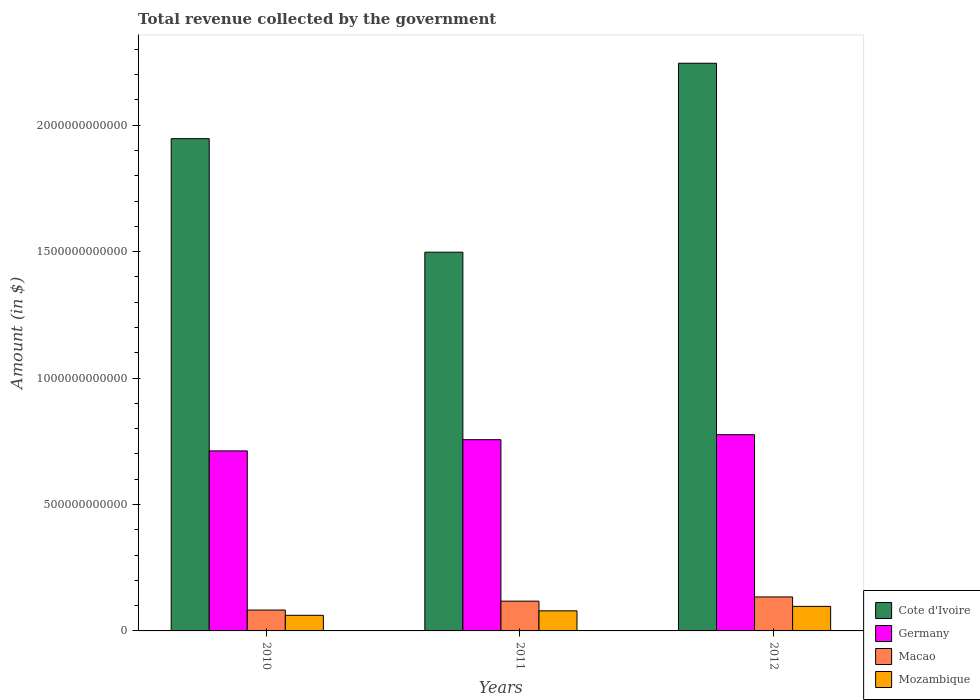How many different coloured bars are there?
Provide a short and direct response. 4. Are the number of bars per tick equal to the number of legend labels?
Offer a very short reply. Yes. How many bars are there on the 3rd tick from the left?
Offer a terse response. 4. In how many cases, is the number of bars for a given year not equal to the number of legend labels?
Keep it short and to the point. 0. What is the total revenue collected by the government in Cote d'Ivoire in 2012?
Give a very brief answer. 2.24e+12. Across all years, what is the maximum total revenue collected by the government in Germany?
Ensure brevity in your answer.  7.76e+11. Across all years, what is the minimum total revenue collected by the government in Cote d'Ivoire?
Provide a succinct answer. 1.50e+12. In which year was the total revenue collected by the government in Germany maximum?
Your answer should be very brief. 2012. What is the total total revenue collected by the government in Cote d'Ivoire in the graph?
Your answer should be compact. 5.69e+12. What is the difference between the total revenue collected by the government in Cote d'Ivoire in 2010 and that in 2011?
Make the answer very short. 4.49e+11. What is the difference between the total revenue collected by the government in Mozambique in 2011 and the total revenue collected by the government in Germany in 2010?
Your answer should be compact. -6.32e+11. What is the average total revenue collected by the government in Mozambique per year?
Your answer should be very brief. 7.94e+1. In the year 2010, what is the difference between the total revenue collected by the government in Mozambique and total revenue collected by the government in Germany?
Give a very brief answer. -6.50e+11. In how many years, is the total revenue collected by the government in Germany greater than 1200000000000 $?
Your response must be concise. 0. What is the ratio of the total revenue collected by the government in Cote d'Ivoire in 2010 to that in 2011?
Your answer should be very brief. 1.3. What is the difference between the highest and the second highest total revenue collected by the government in Mozambique?
Your response must be concise. 1.77e+1. What is the difference between the highest and the lowest total revenue collected by the government in Macao?
Make the answer very short. 5.18e+1. Is the sum of the total revenue collected by the government in Mozambique in 2010 and 2011 greater than the maximum total revenue collected by the government in Macao across all years?
Offer a terse response. Yes. Is it the case that in every year, the sum of the total revenue collected by the government in Mozambique and total revenue collected by the government in Macao is greater than the sum of total revenue collected by the government in Cote d'Ivoire and total revenue collected by the government in Germany?
Offer a terse response. No. What does the 3rd bar from the left in 2011 represents?
Keep it short and to the point. Macao. How many bars are there?
Give a very brief answer. 12. What is the difference between two consecutive major ticks on the Y-axis?
Keep it short and to the point. 5.00e+11. Are the values on the major ticks of Y-axis written in scientific E-notation?
Offer a terse response. No. Does the graph contain grids?
Your response must be concise. No. What is the title of the graph?
Offer a very short reply. Total revenue collected by the government. Does "Indonesia" appear as one of the legend labels in the graph?
Your response must be concise. No. What is the label or title of the Y-axis?
Your answer should be very brief. Amount (in $). What is the Amount (in $) of Cote d'Ivoire in 2010?
Make the answer very short. 1.95e+12. What is the Amount (in $) in Germany in 2010?
Your response must be concise. 7.12e+11. What is the Amount (in $) of Macao in 2010?
Keep it short and to the point. 8.26e+1. What is the Amount (in $) of Mozambique in 2010?
Give a very brief answer. 6.17e+1. What is the Amount (in $) of Cote d'Ivoire in 2011?
Provide a succinct answer. 1.50e+12. What is the Amount (in $) in Germany in 2011?
Offer a very short reply. 7.56e+11. What is the Amount (in $) in Macao in 2011?
Offer a terse response. 1.18e+11. What is the Amount (in $) of Mozambique in 2011?
Your answer should be very brief. 7.94e+1. What is the Amount (in $) of Cote d'Ivoire in 2012?
Your answer should be very brief. 2.24e+12. What is the Amount (in $) of Germany in 2012?
Your response must be concise. 7.76e+11. What is the Amount (in $) in Macao in 2012?
Your answer should be compact. 1.34e+11. What is the Amount (in $) of Mozambique in 2012?
Give a very brief answer. 9.71e+1. Across all years, what is the maximum Amount (in $) in Cote d'Ivoire?
Offer a terse response. 2.24e+12. Across all years, what is the maximum Amount (in $) in Germany?
Your response must be concise. 7.76e+11. Across all years, what is the maximum Amount (in $) of Macao?
Offer a very short reply. 1.34e+11. Across all years, what is the maximum Amount (in $) in Mozambique?
Make the answer very short. 9.71e+1. Across all years, what is the minimum Amount (in $) in Cote d'Ivoire?
Your answer should be very brief. 1.50e+12. Across all years, what is the minimum Amount (in $) of Germany?
Ensure brevity in your answer.  7.12e+11. Across all years, what is the minimum Amount (in $) in Macao?
Ensure brevity in your answer.  8.26e+1. Across all years, what is the minimum Amount (in $) in Mozambique?
Ensure brevity in your answer.  6.17e+1. What is the total Amount (in $) of Cote d'Ivoire in the graph?
Offer a very short reply. 5.69e+12. What is the total Amount (in $) of Germany in the graph?
Offer a terse response. 2.24e+12. What is the total Amount (in $) of Macao in the graph?
Offer a very short reply. 3.35e+11. What is the total Amount (in $) of Mozambique in the graph?
Provide a short and direct response. 2.38e+11. What is the difference between the Amount (in $) in Cote d'Ivoire in 2010 and that in 2011?
Offer a terse response. 4.49e+11. What is the difference between the Amount (in $) in Germany in 2010 and that in 2011?
Keep it short and to the point. -4.44e+1. What is the difference between the Amount (in $) of Macao in 2010 and that in 2011?
Your answer should be very brief. -3.52e+1. What is the difference between the Amount (in $) of Mozambique in 2010 and that in 2011?
Your answer should be very brief. -1.77e+1. What is the difference between the Amount (in $) in Cote d'Ivoire in 2010 and that in 2012?
Provide a short and direct response. -2.98e+11. What is the difference between the Amount (in $) in Germany in 2010 and that in 2012?
Offer a very short reply. -6.41e+1. What is the difference between the Amount (in $) of Macao in 2010 and that in 2012?
Keep it short and to the point. -5.18e+1. What is the difference between the Amount (in $) in Mozambique in 2010 and that in 2012?
Make the answer very short. -3.54e+1. What is the difference between the Amount (in $) of Cote d'Ivoire in 2011 and that in 2012?
Make the answer very short. -7.47e+11. What is the difference between the Amount (in $) in Germany in 2011 and that in 2012?
Give a very brief answer. -1.98e+1. What is the difference between the Amount (in $) in Macao in 2011 and that in 2012?
Your answer should be very brief. -1.66e+1. What is the difference between the Amount (in $) of Mozambique in 2011 and that in 2012?
Make the answer very short. -1.77e+1. What is the difference between the Amount (in $) of Cote d'Ivoire in 2010 and the Amount (in $) of Germany in 2011?
Provide a succinct answer. 1.19e+12. What is the difference between the Amount (in $) of Cote d'Ivoire in 2010 and the Amount (in $) of Macao in 2011?
Keep it short and to the point. 1.83e+12. What is the difference between the Amount (in $) of Cote d'Ivoire in 2010 and the Amount (in $) of Mozambique in 2011?
Your response must be concise. 1.87e+12. What is the difference between the Amount (in $) in Germany in 2010 and the Amount (in $) in Macao in 2011?
Give a very brief answer. 5.94e+11. What is the difference between the Amount (in $) in Germany in 2010 and the Amount (in $) in Mozambique in 2011?
Your answer should be very brief. 6.32e+11. What is the difference between the Amount (in $) in Macao in 2010 and the Amount (in $) in Mozambique in 2011?
Make the answer very short. 3.12e+09. What is the difference between the Amount (in $) of Cote d'Ivoire in 2010 and the Amount (in $) of Germany in 2012?
Provide a succinct answer. 1.17e+12. What is the difference between the Amount (in $) in Cote d'Ivoire in 2010 and the Amount (in $) in Macao in 2012?
Make the answer very short. 1.81e+12. What is the difference between the Amount (in $) in Cote d'Ivoire in 2010 and the Amount (in $) in Mozambique in 2012?
Ensure brevity in your answer.  1.85e+12. What is the difference between the Amount (in $) of Germany in 2010 and the Amount (in $) of Macao in 2012?
Ensure brevity in your answer.  5.78e+11. What is the difference between the Amount (in $) in Germany in 2010 and the Amount (in $) in Mozambique in 2012?
Offer a terse response. 6.15e+11. What is the difference between the Amount (in $) of Macao in 2010 and the Amount (in $) of Mozambique in 2012?
Your answer should be compact. -1.46e+1. What is the difference between the Amount (in $) in Cote d'Ivoire in 2011 and the Amount (in $) in Germany in 2012?
Make the answer very short. 7.22e+11. What is the difference between the Amount (in $) of Cote d'Ivoire in 2011 and the Amount (in $) of Macao in 2012?
Give a very brief answer. 1.36e+12. What is the difference between the Amount (in $) in Cote d'Ivoire in 2011 and the Amount (in $) in Mozambique in 2012?
Keep it short and to the point. 1.40e+12. What is the difference between the Amount (in $) in Germany in 2011 and the Amount (in $) in Macao in 2012?
Your response must be concise. 6.22e+11. What is the difference between the Amount (in $) of Germany in 2011 and the Amount (in $) of Mozambique in 2012?
Your answer should be very brief. 6.59e+11. What is the difference between the Amount (in $) in Macao in 2011 and the Amount (in $) in Mozambique in 2012?
Your answer should be very brief. 2.06e+1. What is the average Amount (in $) of Cote d'Ivoire per year?
Keep it short and to the point. 1.90e+12. What is the average Amount (in $) of Germany per year?
Your response must be concise. 7.48e+11. What is the average Amount (in $) of Macao per year?
Make the answer very short. 1.12e+11. What is the average Amount (in $) of Mozambique per year?
Offer a terse response. 7.94e+1. In the year 2010, what is the difference between the Amount (in $) in Cote d'Ivoire and Amount (in $) in Germany?
Provide a short and direct response. 1.23e+12. In the year 2010, what is the difference between the Amount (in $) in Cote d'Ivoire and Amount (in $) in Macao?
Offer a very short reply. 1.86e+12. In the year 2010, what is the difference between the Amount (in $) in Cote d'Ivoire and Amount (in $) in Mozambique?
Your response must be concise. 1.88e+12. In the year 2010, what is the difference between the Amount (in $) in Germany and Amount (in $) in Macao?
Provide a short and direct response. 6.29e+11. In the year 2010, what is the difference between the Amount (in $) in Germany and Amount (in $) in Mozambique?
Give a very brief answer. 6.50e+11. In the year 2010, what is the difference between the Amount (in $) in Macao and Amount (in $) in Mozambique?
Provide a succinct answer. 2.09e+1. In the year 2011, what is the difference between the Amount (in $) of Cote d'Ivoire and Amount (in $) of Germany?
Offer a very short reply. 7.41e+11. In the year 2011, what is the difference between the Amount (in $) in Cote d'Ivoire and Amount (in $) in Macao?
Offer a terse response. 1.38e+12. In the year 2011, what is the difference between the Amount (in $) of Cote d'Ivoire and Amount (in $) of Mozambique?
Offer a terse response. 1.42e+12. In the year 2011, what is the difference between the Amount (in $) in Germany and Amount (in $) in Macao?
Offer a very short reply. 6.38e+11. In the year 2011, what is the difference between the Amount (in $) of Germany and Amount (in $) of Mozambique?
Your answer should be very brief. 6.77e+11. In the year 2011, what is the difference between the Amount (in $) of Macao and Amount (in $) of Mozambique?
Keep it short and to the point. 3.83e+1. In the year 2012, what is the difference between the Amount (in $) in Cote d'Ivoire and Amount (in $) in Germany?
Offer a very short reply. 1.47e+12. In the year 2012, what is the difference between the Amount (in $) of Cote d'Ivoire and Amount (in $) of Macao?
Offer a very short reply. 2.11e+12. In the year 2012, what is the difference between the Amount (in $) of Cote d'Ivoire and Amount (in $) of Mozambique?
Offer a terse response. 2.15e+12. In the year 2012, what is the difference between the Amount (in $) of Germany and Amount (in $) of Macao?
Provide a succinct answer. 6.42e+11. In the year 2012, what is the difference between the Amount (in $) in Germany and Amount (in $) in Mozambique?
Offer a terse response. 6.79e+11. In the year 2012, what is the difference between the Amount (in $) in Macao and Amount (in $) in Mozambique?
Offer a terse response. 3.72e+1. What is the ratio of the Amount (in $) in Cote d'Ivoire in 2010 to that in 2011?
Give a very brief answer. 1.3. What is the ratio of the Amount (in $) in Germany in 2010 to that in 2011?
Your response must be concise. 0.94. What is the ratio of the Amount (in $) of Macao in 2010 to that in 2011?
Offer a terse response. 0.7. What is the ratio of the Amount (in $) in Mozambique in 2010 to that in 2011?
Your answer should be very brief. 0.78. What is the ratio of the Amount (in $) of Cote d'Ivoire in 2010 to that in 2012?
Offer a very short reply. 0.87. What is the ratio of the Amount (in $) of Germany in 2010 to that in 2012?
Your answer should be very brief. 0.92. What is the ratio of the Amount (in $) of Macao in 2010 to that in 2012?
Ensure brevity in your answer.  0.61. What is the ratio of the Amount (in $) of Mozambique in 2010 to that in 2012?
Provide a short and direct response. 0.64. What is the ratio of the Amount (in $) in Cote d'Ivoire in 2011 to that in 2012?
Provide a short and direct response. 0.67. What is the ratio of the Amount (in $) in Germany in 2011 to that in 2012?
Provide a succinct answer. 0.97. What is the ratio of the Amount (in $) of Macao in 2011 to that in 2012?
Make the answer very short. 0.88. What is the ratio of the Amount (in $) of Mozambique in 2011 to that in 2012?
Keep it short and to the point. 0.82. What is the difference between the highest and the second highest Amount (in $) in Cote d'Ivoire?
Your response must be concise. 2.98e+11. What is the difference between the highest and the second highest Amount (in $) in Germany?
Keep it short and to the point. 1.98e+1. What is the difference between the highest and the second highest Amount (in $) of Macao?
Provide a succinct answer. 1.66e+1. What is the difference between the highest and the second highest Amount (in $) of Mozambique?
Your response must be concise. 1.77e+1. What is the difference between the highest and the lowest Amount (in $) of Cote d'Ivoire?
Provide a succinct answer. 7.47e+11. What is the difference between the highest and the lowest Amount (in $) of Germany?
Offer a terse response. 6.41e+1. What is the difference between the highest and the lowest Amount (in $) in Macao?
Keep it short and to the point. 5.18e+1. What is the difference between the highest and the lowest Amount (in $) of Mozambique?
Keep it short and to the point. 3.54e+1. 